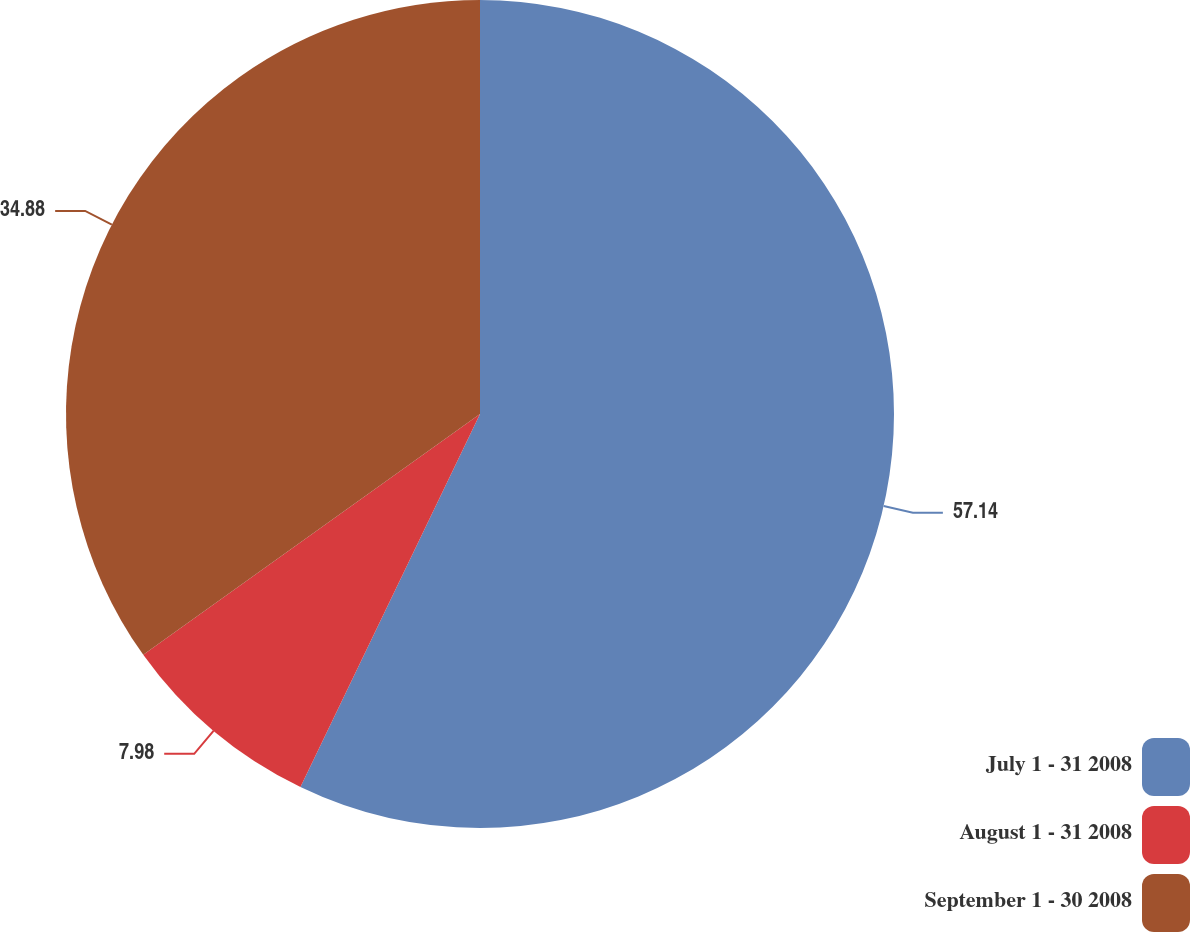<chart> <loc_0><loc_0><loc_500><loc_500><pie_chart><fcel>July 1 - 31 2008<fcel>August 1 - 31 2008<fcel>September 1 - 30 2008<nl><fcel>57.14%<fcel>7.98%<fcel>34.88%<nl></chart> 